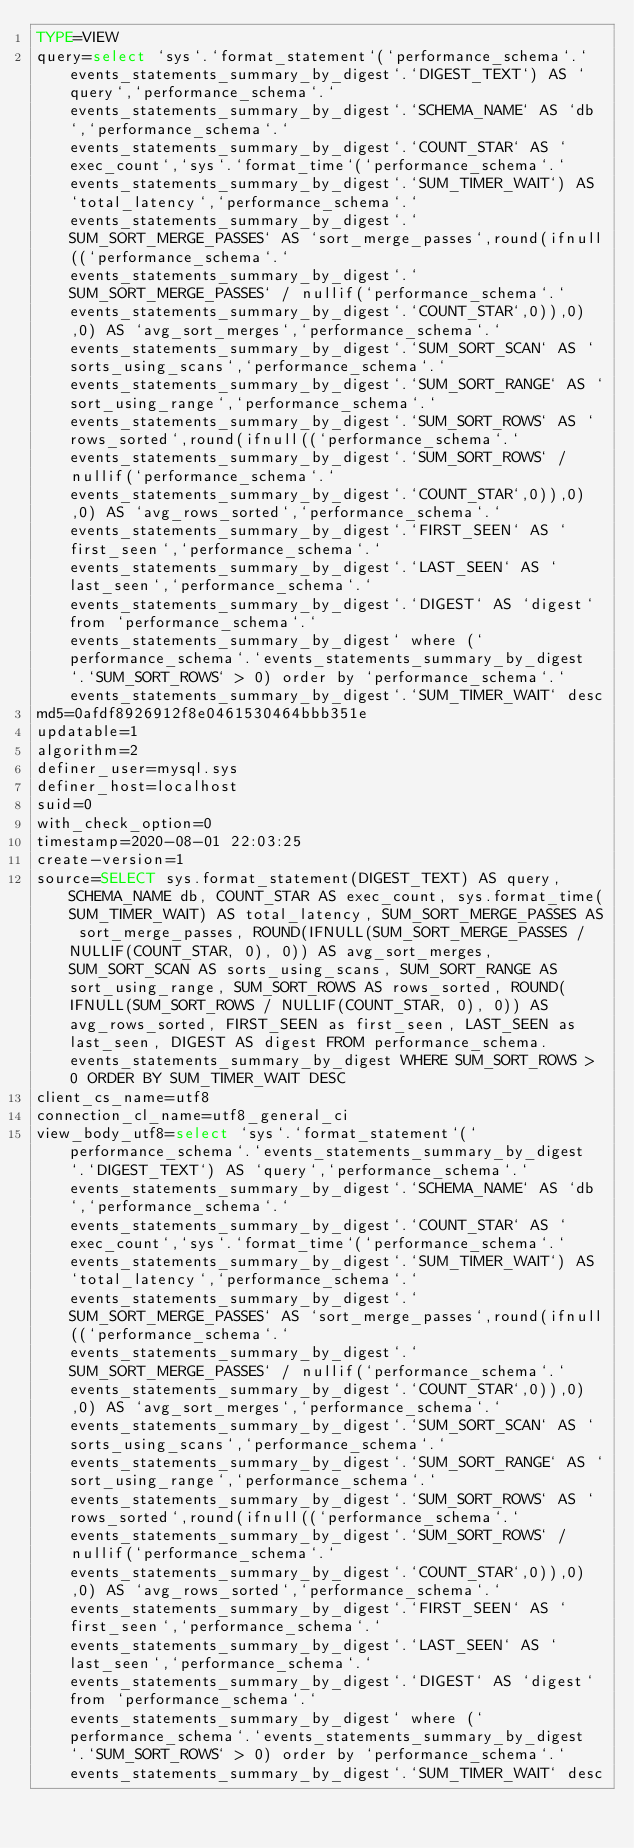Convert code to text. <code><loc_0><loc_0><loc_500><loc_500><_VisualBasic_>TYPE=VIEW
query=select `sys`.`format_statement`(`performance_schema`.`events_statements_summary_by_digest`.`DIGEST_TEXT`) AS `query`,`performance_schema`.`events_statements_summary_by_digest`.`SCHEMA_NAME` AS `db`,`performance_schema`.`events_statements_summary_by_digest`.`COUNT_STAR` AS `exec_count`,`sys`.`format_time`(`performance_schema`.`events_statements_summary_by_digest`.`SUM_TIMER_WAIT`) AS `total_latency`,`performance_schema`.`events_statements_summary_by_digest`.`SUM_SORT_MERGE_PASSES` AS `sort_merge_passes`,round(ifnull((`performance_schema`.`events_statements_summary_by_digest`.`SUM_SORT_MERGE_PASSES` / nullif(`performance_schema`.`events_statements_summary_by_digest`.`COUNT_STAR`,0)),0),0) AS `avg_sort_merges`,`performance_schema`.`events_statements_summary_by_digest`.`SUM_SORT_SCAN` AS `sorts_using_scans`,`performance_schema`.`events_statements_summary_by_digest`.`SUM_SORT_RANGE` AS `sort_using_range`,`performance_schema`.`events_statements_summary_by_digest`.`SUM_SORT_ROWS` AS `rows_sorted`,round(ifnull((`performance_schema`.`events_statements_summary_by_digest`.`SUM_SORT_ROWS` / nullif(`performance_schema`.`events_statements_summary_by_digest`.`COUNT_STAR`,0)),0),0) AS `avg_rows_sorted`,`performance_schema`.`events_statements_summary_by_digest`.`FIRST_SEEN` AS `first_seen`,`performance_schema`.`events_statements_summary_by_digest`.`LAST_SEEN` AS `last_seen`,`performance_schema`.`events_statements_summary_by_digest`.`DIGEST` AS `digest` from `performance_schema`.`events_statements_summary_by_digest` where (`performance_schema`.`events_statements_summary_by_digest`.`SUM_SORT_ROWS` > 0) order by `performance_schema`.`events_statements_summary_by_digest`.`SUM_TIMER_WAIT` desc
md5=0afdf8926912f8e0461530464bbb351e
updatable=1
algorithm=2
definer_user=mysql.sys
definer_host=localhost
suid=0
with_check_option=0
timestamp=2020-08-01 22:03:25
create-version=1
source=SELECT sys.format_statement(DIGEST_TEXT) AS query, SCHEMA_NAME db, COUNT_STAR AS exec_count, sys.format_time(SUM_TIMER_WAIT) AS total_latency, SUM_SORT_MERGE_PASSES AS sort_merge_passes, ROUND(IFNULL(SUM_SORT_MERGE_PASSES / NULLIF(COUNT_STAR, 0), 0)) AS avg_sort_merges, SUM_SORT_SCAN AS sorts_using_scans, SUM_SORT_RANGE AS sort_using_range, SUM_SORT_ROWS AS rows_sorted, ROUND(IFNULL(SUM_SORT_ROWS / NULLIF(COUNT_STAR, 0), 0)) AS avg_rows_sorted, FIRST_SEEN as first_seen, LAST_SEEN as last_seen, DIGEST AS digest FROM performance_schema.events_statements_summary_by_digest WHERE SUM_SORT_ROWS > 0 ORDER BY SUM_TIMER_WAIT DESC
client_cs_name=utf8
connection_cl_name=utf8_general_ci
view_body_utf8=select `sys`.`format_statement`(`performance_schema`.`events_statements_summary_by_digest`.`DIGEST_TEXT`) AS `query`,`performance_schema`.`events_statements_summary_by_digest`.`SCHEMA_NAME` AS `db`,`performance_schema`.`events_statements_summary_by_digest`.`COUNT_STAR` AS `exec_count`,`sys`.`format_time`(`performance_schema`.`events_statements_summary_by_digest`.`SUM_TIMER_WAIT`) AS `total_latency`,`performance_schema`.`events_statements_summary_by_digest`.`SUM_SORT_MERGE_PASSES` AS `sort_merge_passes`,round(ifnull((`performance_schema`.`events_statements_summary_by_digest`.`SUM_SORT_MERGE_PASSES` / nullif(`performance_schema`.`events_statements_summary_by_digest`.`COUNT_STAR`,0)),0),0) AS `avg_sort_merges`,`performance_schema`.`events_statements_summary_by_digest`.`SUM_SORT_SCAN` AS `sorts_using_scans`,`performance_schema`.`events_statements_summary_by_digest`.`SUM_SORT_RANGE` AS `sort_using_range`,`performance_schema`.`events_statements_summary_by_digest`.`SUM_SORT_ROWS` AS `rows_sorted`,round(ifnull((`performance_schema`.`events_statements_summary_by_digest`.`SUM_SORT_ROWS` / nullif(`performance_schema`.`events_statements_summary_by_digest`.`COUNT_STAR`,0)),0),0) AS `avg_rows_sorted`,`performance_schema`.`events_statements_summary_by_digest`.`FIRST_SEEN` AS `first_seen`,`performance_schema`.`events_statements_summary_by_digest`.`LAST_SEEN` AS `last_seen`,`performance_schema`.`events_statements_summary_by_digest`.`DIGEST` AS `digest` from `performance_schema`.`events_statements_summary_by_digest` where (`performance_schema`.`events_statements_summary_by_digest`.`SUM_SORT_ROWS` > 0) order by `performance_schema`.`events_statements_summary_by_digest`.`SUM_TIMER_WAIT` desc
</code> 